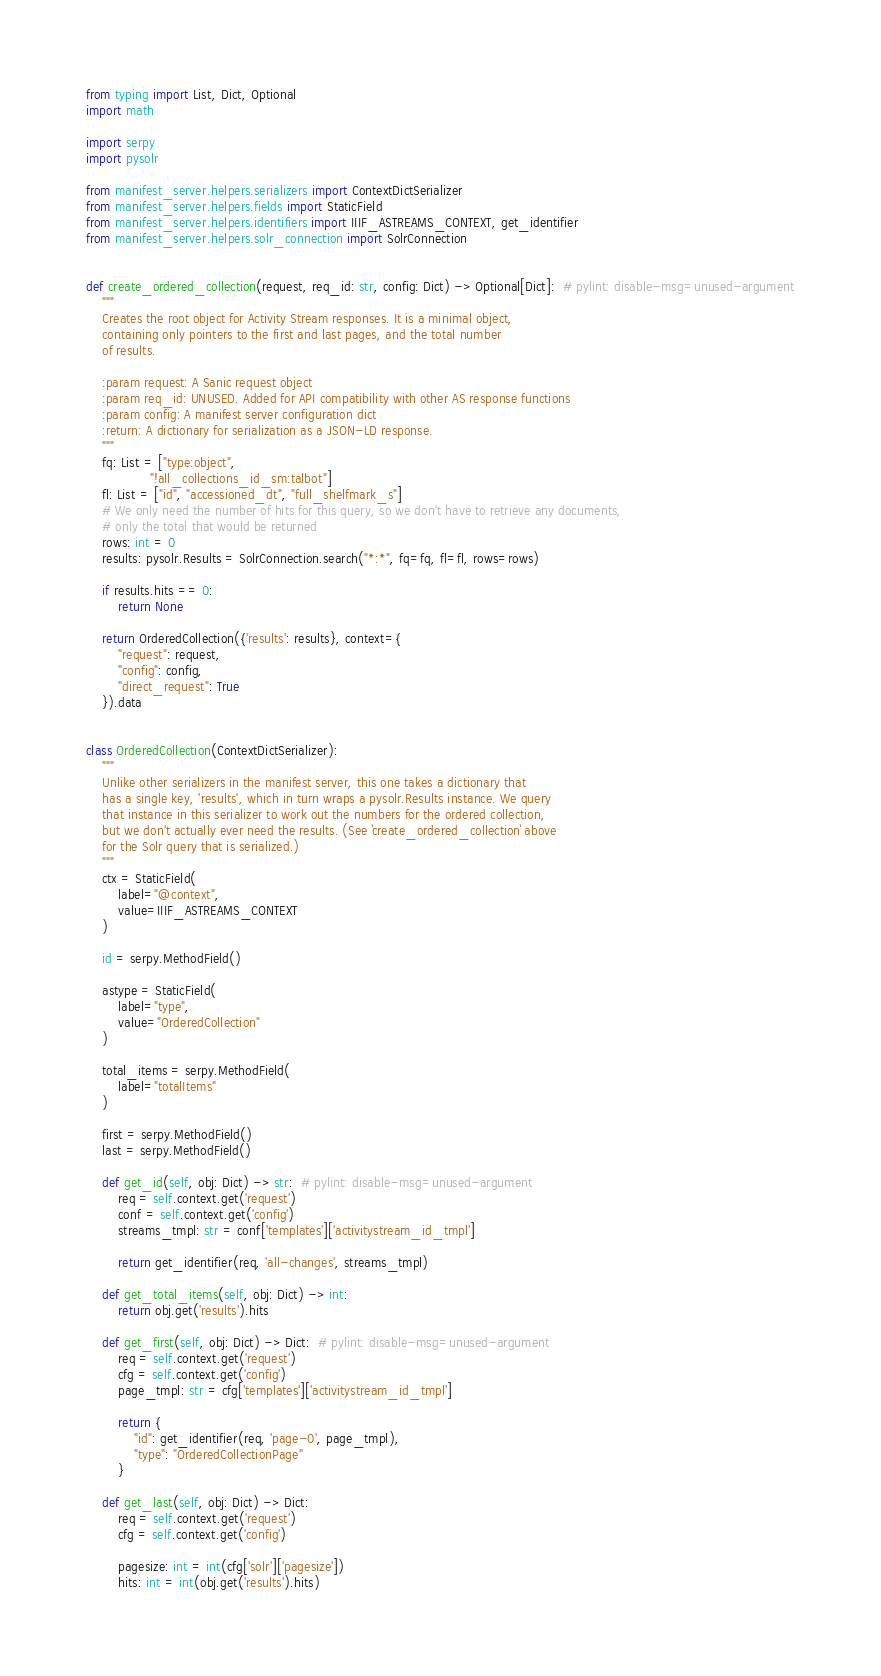Convert code to text. <code><loc_0><loc_0><loc_500><loc_500><_Python_>from typing import List, Dict, Optional
import math

import serpy
import pysolr

from manifest_server.helpers.serializers import ContextDictSerializer
from manifest_server.helpers.fields import StaticField
from manifest_server.helpers.identifiers import IIIF_ASTREAMS_CONTEXT, get_identifier
from manifest_server.helpers.solr_connection import SolrConnection


def create_ordered_collection(request, req_id: str, config: Dict) -> Optional[Dict]:  # pylint: disable-msg=unused-argument
    """
    Creates the root object for Activity Stream responses. It is a minimal object,
    containing only pointers to the first and last pages, and the total number
    of results.

    :param request: A Sanic request object
    :param req_id: UNUSED. Added for API compatibility with other AS response functions
    :param config: A manifest server configuration dict
    :return: A dictionary for serialization as a JSON-LD response.
    """
    fq: List = ["type:object",
                "!all_collections_id_sm:talbot"]
    fl: List = ["id", "accessioned_dt", "full_shelfmark_s"]
    # We only need the number of hits for this query, so we don't have to retrieve any documents,
    # only the total that would be returned
    rows: int = 0
    results: pysolr.Results = SolrConnection.search("*:*", fq=fq, fl=fl, rows=rows)

    if results.hits == 0:
        return None

    return OrderedCollection({'results': results}, context={
        "request": request,
        "config": config,
        "direct_request": True
    }).data


class OrderedCollection(ContextDictSerializer):
    """
    Unlike other serializers in the manifest server, this one takes a dictionary that
    has a single key, 'results', which in turn wraps a pysolr.Results instance. We query
    that instance in this serializer to work out the numbers for the ordered collection,
    but we don't actually ever need the results. (See `create_ordered_collection` above
    for the Solr query that is serialized.)
    """
    ctx = StaticField(
        label="@context",
        value=IIIF_ASTREAMS_CONTEXT
    )

    id = serpy.MethodField()

    astype = StaticField(
        label="type",
        value="OrderedCollection"
    )

    total_items = serpy.MethodField(
        label="totalItems"
    )

    first = serpy.MethodField()
    last = serpy.MethodField()

    def get_id(self, obj: Dict) -> str:  # pylint: disable-msg=unused-argument
        req = self.context.get('request')
        conf = self.context.get('config')
        streams_tmpl: str = conf['templates']['activitystream_id_tmpl']

        return get_identifier(req, 'all-changes', streams_tmpl)

    def get_total_items(self, obj: Dict) -> int:
        return obj.get('results').hits

    def get_first(self, obj: Dict) -> Dict:  # pylint: disable-msg=unused-argument
        req = self.context.get('request')
        cfg = self.context.get('config')
        page_tmpl: str = cfg['templates']['activitystream_id_tmpl']

        return {
            "id": get_identifier(req, 'page-0', page_tmpl),
            "type": "OrderedCollectionPage"
        }

    def get_last(self, obj: Dict) -> Dict:
        req = self.context.get('request')
        cfg = self.context.get('config')

        pagesize: int = int(cfg['solr']['pagesize'])
        hits: int = int(obj.get('results').hits)</code> 